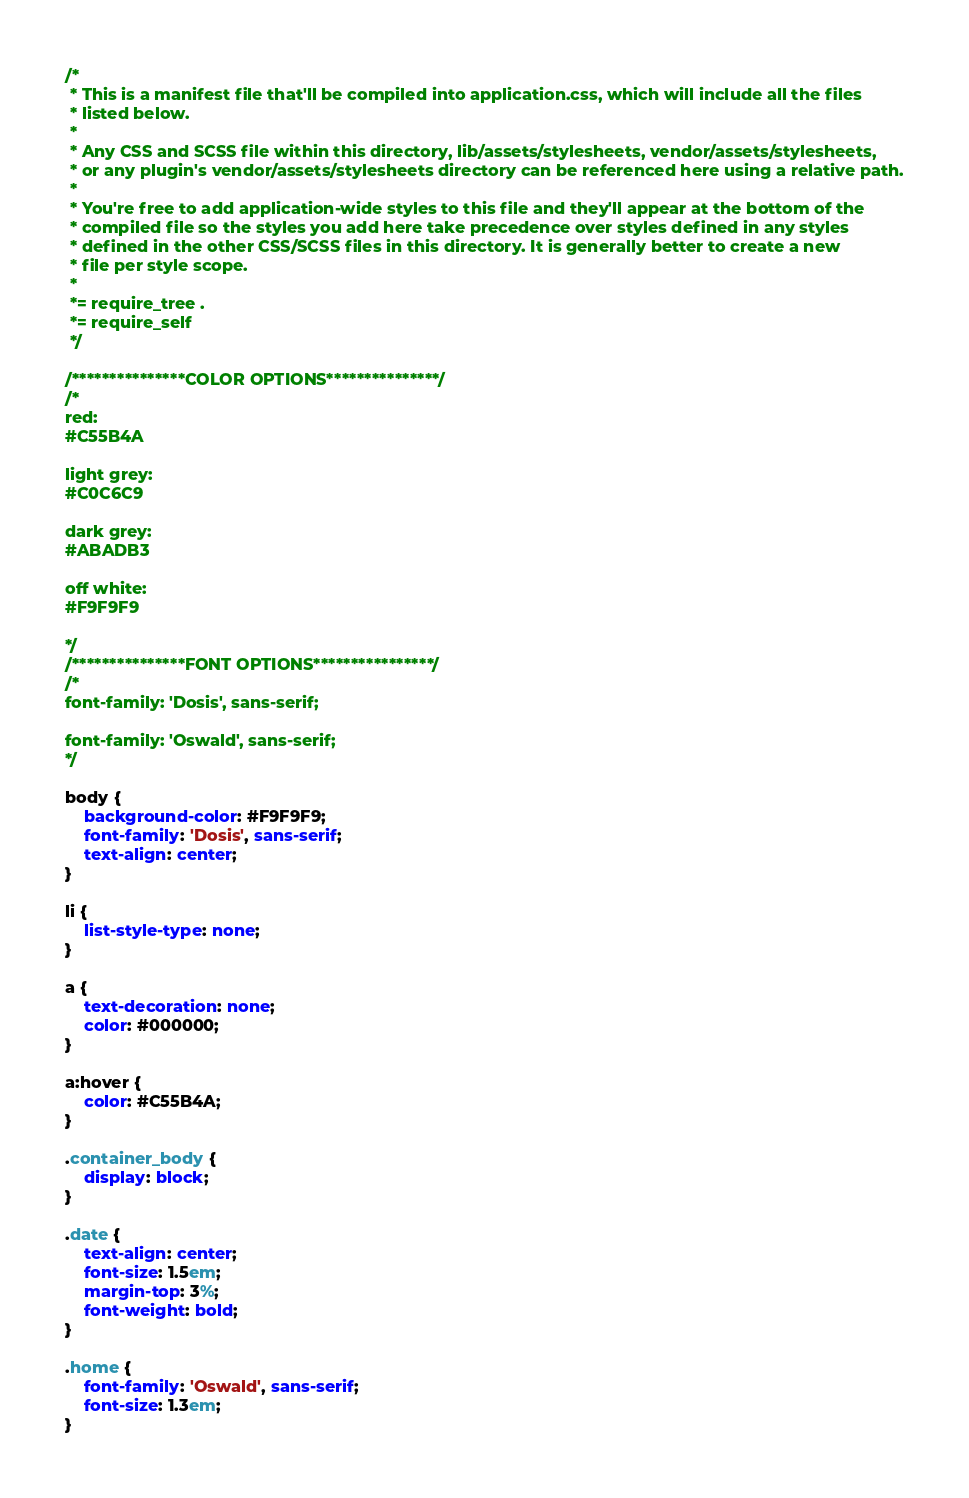Convert code to text. <code><loc_0><loc_0><loc_500><loc_500><_CSS_>/*
 * This is a manifest file that'll be compiled into application.css, which will include all the files
 * listed below.
 *
 * Any CSS and SCSS file within this directory, lib/assets/stylesheets, vendor/assets/stylesheets,
 * or any plugin's vendor/assets/stylesheets directory can be referenced here using a relative path.
 *
 * You're free to add application-wide styles to this file and they'll appear at the bottom of the
 * compiled file so the styles you add here take precedence over styles defined in any styles
 * defined in the other CSS/SCSS files in this directory. It is generally better to create a new
 * file per style scope.
 *
 *= require_tree .
 *= require_self
 */

/***************COLOR OPTIONS***************/
/*
red: 
#C55B4A

light grey:
#C0C6C9

dark grey:
#ABADB3

off white: 
#F9F9F9

*/
/***************FONT OPTIONS****************/
/*
font-family: 'Dosis', sans-serif;

font-family: 'Oswald', sans-serif;
*/

body {
	background-color: #F9F9F9;
	font-family: 'Dosis', sans-serif;
	text-align: center;
}

li {
	list-style-type: none;
}

a {
	text-decoration: none;
	color: #000000;
}

a:hover {
	color: #C55B4A;
}

.container_body {
	display: block;
}

.date {
	text-align: center;
	font-size: 1.5em;
	margin-top: 3%;
	font-weight: bold;
}

.home {
	font-family: 'Oswald', sans-serif;
	font-size: 1.3em;
}</code> 